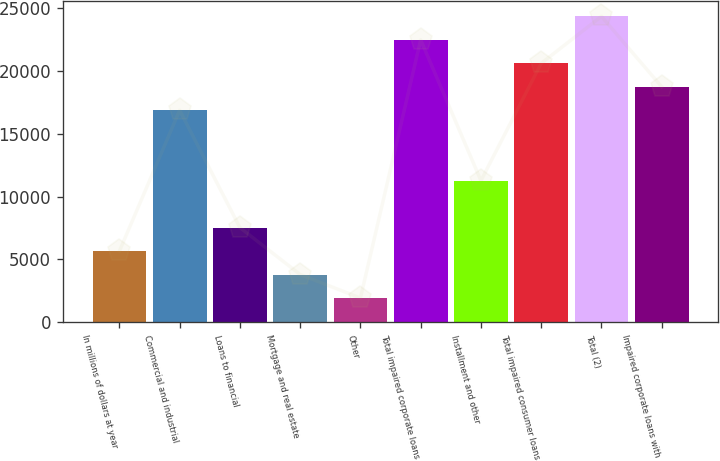Convert chart to OTSL. <chart><loc_0><loc_0><loc_500><loc_500><bar_chart><fcel>In millions of dollars at year<fcel>Commercial and industrial<fcel>Loans to financial<fcel>Mortgage and real estate<fcel>Other<fcel>Total impaired corporate loans<fcel>Installment and other<fcel>Total impaired consumer loans<fcel>Total (2)<fcel>Impaired corporate loans with<nl><fcel>5657.2<fcel>16873.6<fcel>7526.6<fcel>3787.8<fcel>1918.4<fcel>22481.8<fcel>11265.4<fcel>20612.4<fcel>24351.2<fcel>18743<nl></chart> 